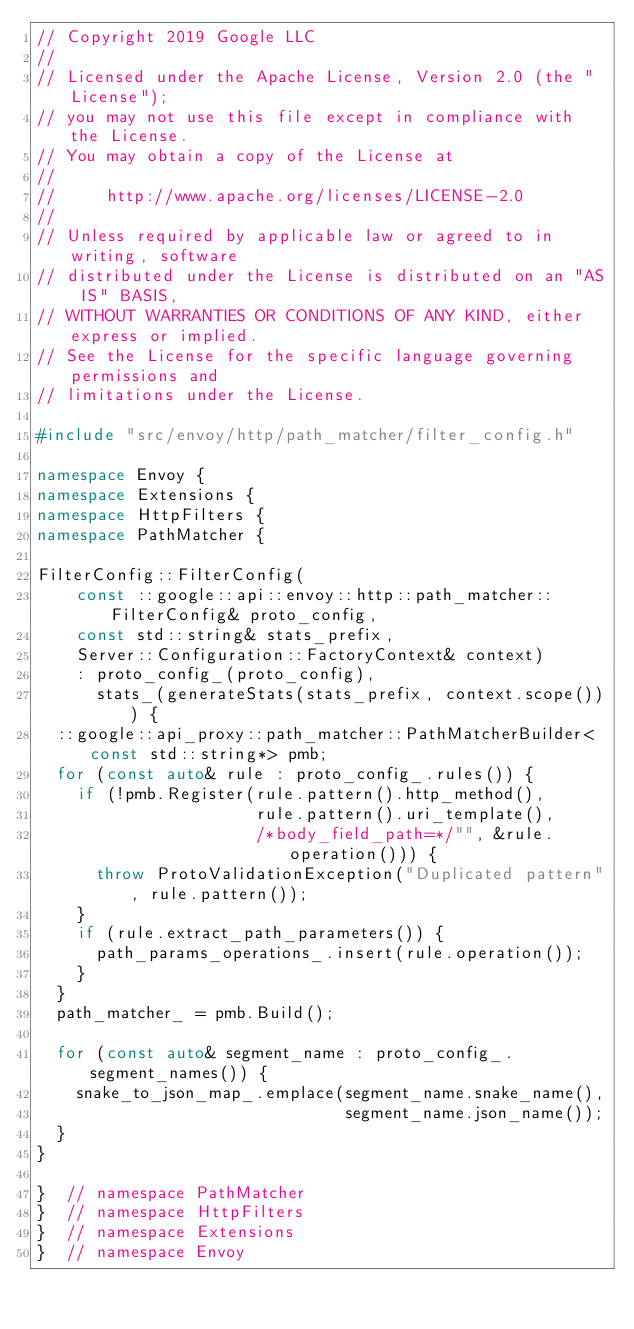<code> <loc_0><loc_0><loc_500><loc_500><_C++_>// Copyright 2019 Google LLC
//
// Licensed under the Apache License, Version 2.0 (the "License");
// you may not use this file except in compliance with the License.
// You may obtain a copy of the License at
//
//     http://www.apache.org/licenses/LICENSE-2.0
//
// Unless required by applicable law or agreed to in writing, software
// distributed under the License is distributed on an "AS IS" BASIS,
// WITHOUT WARRANTIES OR CONDITIONS OF ANY KIND, either express or implied.
// See the License for the specific language governing permissions and
// limitations under the License.

#include "src/envoy/http/path_matcher/filter_config.h"

namespace Envoy {
namespace Extensions {
namespace HttpFilters {
namespace PathMatcher {

FilterConfig::FilterConfig(
    const ::google::api::envoy::http::path_matcher::FilterConfig& proto_config,
    const std::string& stats_prefix,
    Server::Configuration::FactoryContext& context)
    : proto_config_(proto_config),
      stats_(generateStats(stats_prefix, context.scope())) {
  ::google::api_proxy::path_matcher::PathMatcherBuilder<const std::string*> pmb;
  for (const auto& rule : proto_config_.rules()) {
    if (!pmb.Register(rule.pattern().http_method(),
                      rule.pattern().uri_template(),
                      /*body_field_path=*/"", &rule.operation())) {
      throw ProtoValidationException("Duplicated pattern", rule.pattern());
    }
    if (rule.extract_path_parameters()) {
      path_params_operations_.insert(rule.operation());
    }
  }
  path_matcher_ = pmb.Build();

  for (const auto& segment_name : proto_config_.segment_names()) {
    snake_to_json_map_.emplace(segment_name.snake_name(),
                               segment_name.json_name());
  }
}

}  // namespace PathMatcher
}  // namespace HttpFilters
}  // namespace Extensions
}  // namespace Envoy
</code> 